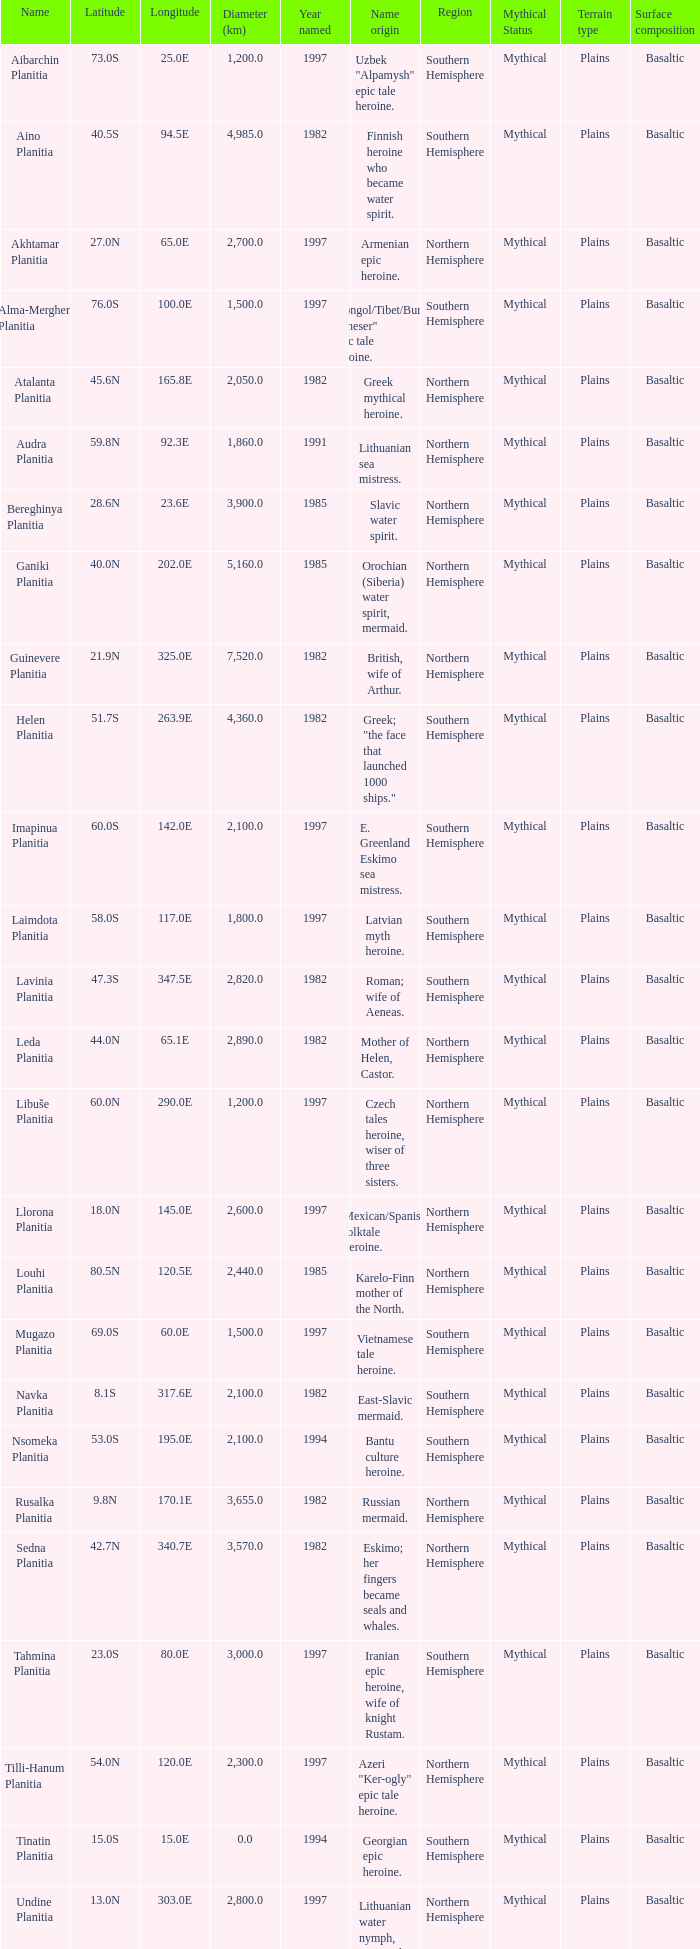What is the diameter (km) of feature of latitude 40.5s 4985.0. 